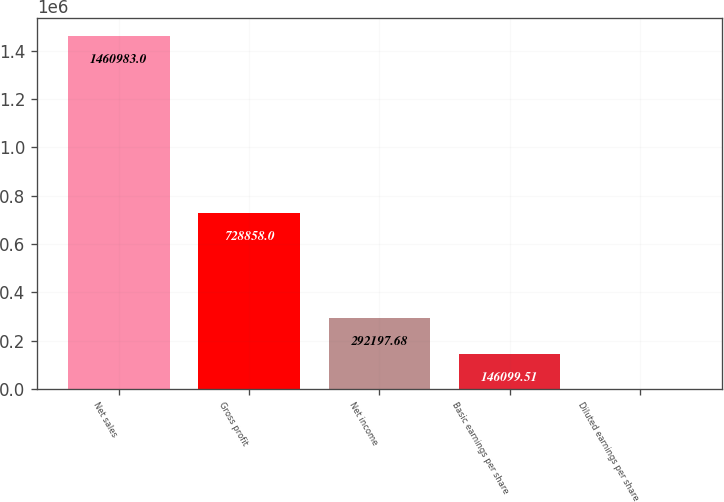Convert chart. <chart><loc_0><loc_0><loc_500><loc_500><bar_chart><fcel>Net sales<fcel>Gross profit<fcel>Net income<fcel>Basic earnings per share<fcel>Diluted earnings per share<nl><fcel>1.46098e+06<fcel>728858<fcel>292198<fcel>146100<fcel>1.34<nl></chart> 